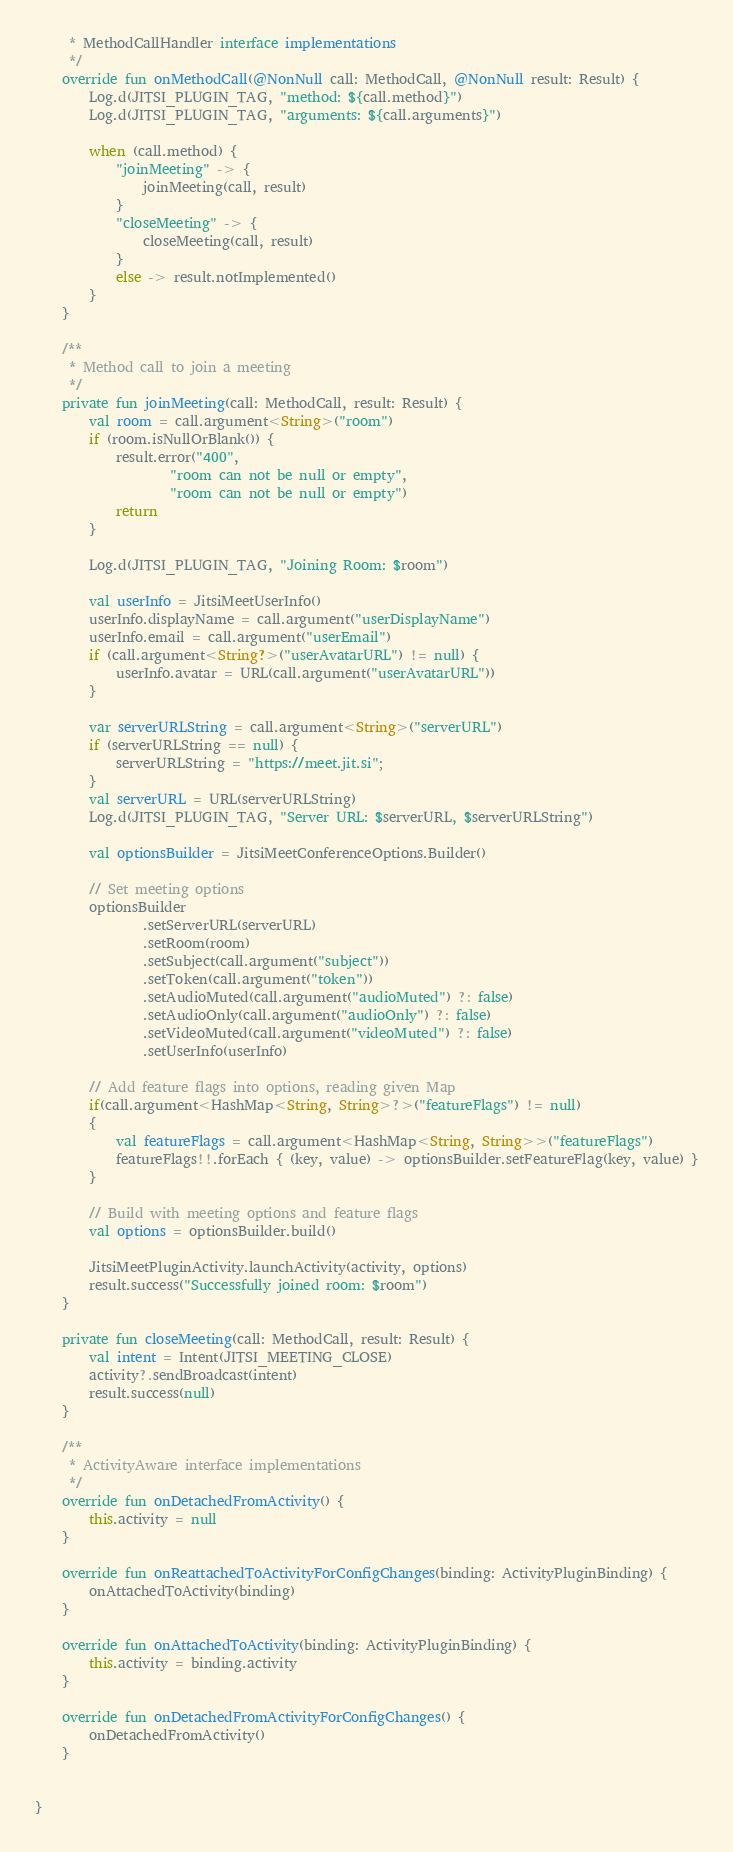<code> <loc_0><loc_0><loc_500><loc_500><_Kotlin_>     * MethodCallHandler interface implementations
     */
    override fun onMethodCall(@NonNull call: MethodCall, @NonNull result: Result) {
        Log.d(JITSI_PLUGIN_TAG, "method: ${call.method}")
        Log.d(JITSI_PLUGIN_TAG, "arguments: ${call.arguments}")

        when (call.method) {
            "joinMeeting" -> {
                joinMeeting(call, result)
            }
            "closeMeeting" -> {
                closeMeeting(call, result)
            }
            else -> result.notImplemented()
        }
    }

    /**
     * Method call to join a meeting
     */
    private fun joinMeeting(call: MethodCall, result: Result) {
        val room = call.argument<String>("room")
        if (room.isNullOrBlank()) {
            result.error("400",
                    "room can not be null or empty",
                    "room can not be null or empty")
            return
        }

        Log.d(JITSI_PLUGIN_TAG, "Joining Room: $room")

        val userInfo = JitsiMeetUserInfo()
        userInfo.displayName = call.argument("userDisplayName")
        userInfo.email = call.argument("userEmail")
        if (call.argument<String?>("userAvatarURL") != null) {
            userInfo.avatar = URL(call.argument("userAvatarURL"))
        }

        var serverURLString = call.argument<String>("serverURL")
        if (serverURLString == null) {
            serverURLString = "https://meet.jit.si";
        }
        val serverURL = URL(serverURLString)
        Log.d(JITSI_PLUGIN_TAG, "Server URL: $serverURL, $serverURLString")

        val optionsBuilder = JitsiMeetConferenceOptions.Builder()

        // Set meeting options
        optionsBuilder
                .setServerURL(serverURL)
                .setRoom(room)
                .setSubject(call.argument("subject"))
                .setToken(call.argument("token"))
                .setAudioMuted(call.argument("audioMuted") ?: false)
                .setAudioOnly(call.argument("audioOnly") ?: false)
                .setVideoMuted(call.argument("videoMuted") ?: false)
                .setUserInfo(userInfo)

        // Add feature flags into options, reading given Map
        if(call.argument<HashMap<String, String>?>("featureFlags") != null)
        {
            val featureFlags = call.argument<HashMap<String, String>>("featureFlags")
            featureFlags!!.forEach { (key, value) -> optionsBuilder.setFeatureFlag(key, value) }
        }

        // Build with meeting options and feature flags
        val options = optionsBuilder.build()

        JitsiMeetPluginActivity.launchActivity(activity, options)
        result.success("Successfully joined room: $room")
    }

    private fun closeMeeting(call: MethodCall, result: Result) {
        val intent = Intent(JITSI_MEETING_CLOSE)
        activity?.sendBroadcast(intent)
        result.success(null)
    }

    /**
     * ActivityAware interface implementations
     */
    override fun onDetachedFromActivity() {
        this.activity = null
    }

    override fun onReattachedToActivityForConfigChanges(binding: ActivityPluginBinding) {
        onAttachedToActivity(binding)
    }

    override fun onAttachedToActivity(binding: ActivityPluginBinding) {
        this.activity = binding.activity
    }

    override fun onDetachedFromActivityForConfigChanges() {
        onDetachedFromActivity()
    }


}
</code> 